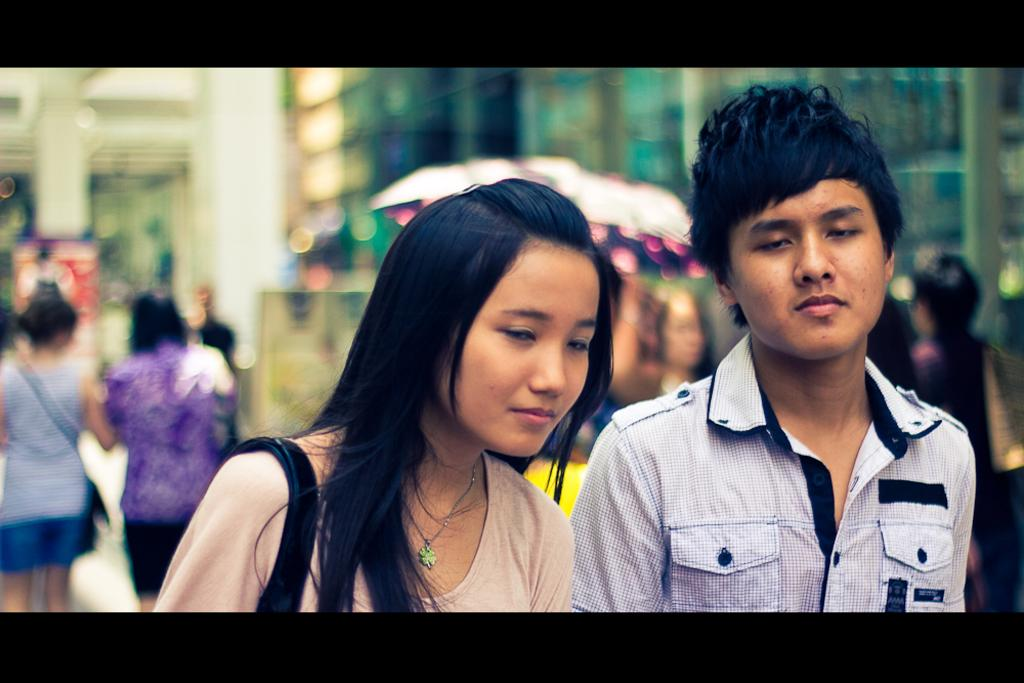How many people are present in the image? There are two persons standing in the image. What is the boy wearing in the image? The boy is wearing a shirt in the image. What can be seen happening in the background of the image? There is a group of people walking in the background of the image. Is there any part of the image that is not clear? Yes, there is a blurry area in the image. What causes the boy to start sneezing in the image? There is no indication in the image that the boy is sneezing or that anything is causing him to sneeze. 